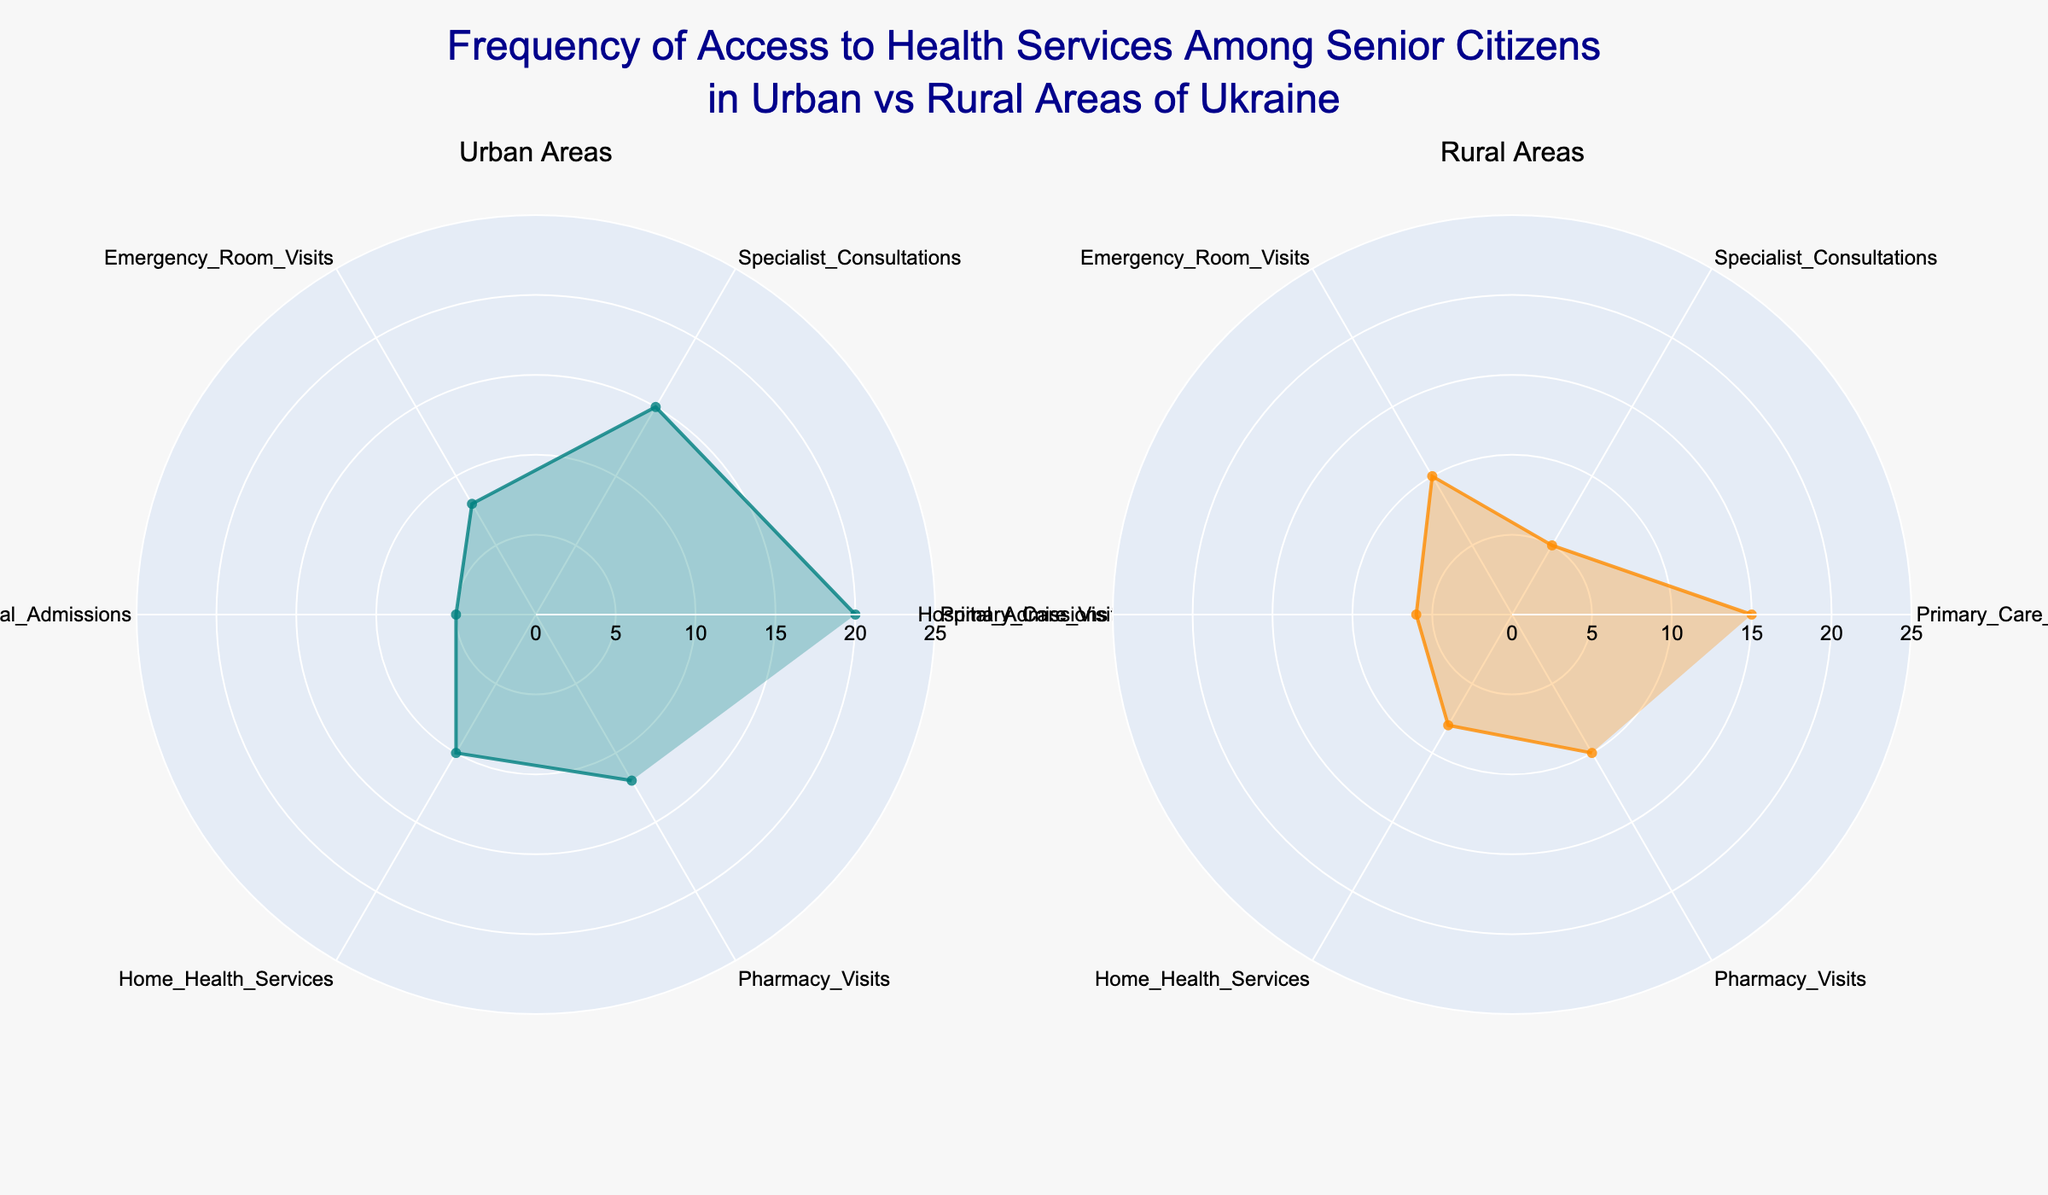What's the title of the figure? The title is located at the top center of the figure and clearly states the subject of the plot.
Answer: "Frequency of Access to Health Services Among Senior Citizens in Urban vs Rural Areas of Ukraine" Which health service has the highest frequency in urban areas? The highest point on the polar plot for urban areas indicates the health service with the highest frequency.
Answer: Primary Care Visits What is the frequency of specialist consultations in rural areas? Look at the data point associated with "Specialist Consultations" in the polar chart for rural areas.
Answer: 5 Which area has a higher frequency of emergency room visits? Compare the "Emergency Room Visits" frequency between the urban and rural areas plots.
Answer: Rural What is the difference in frequency of hospital admissions between urban and rural areas? Find the values for "Hospital Admissions" in both plots and calculate the difference (6 for rural and 5 for urban).
Answer: 1 How many health services in urban areas have a frequency above 10? Count the number of data points in the urban plot that exceed a frequency of 10.
Answer: 3 What are the colors used for the urban and rural areas plot? Observe the fill color and line color for urban and rural areas in the plots.
Answer: Urban: teal; Rural: orange Are home health services accessed more frequently in urban or rural areas? Compare the frequency of "Home Health Services" between the two plots.
Answer: Urban What is the average frequency of pharmacy visits in both areas combined? Sum the frequencies for "Pharmacy Visits" in both areas (Urban: 12, Rural: 10) and divide by 2.
Answer: 11 Which health service shows the most similar frequency between urban and rural areas? Compare the frequencies for each health service between the two areas and identify the smallest difference.
Answer: Pharmacy Visits 